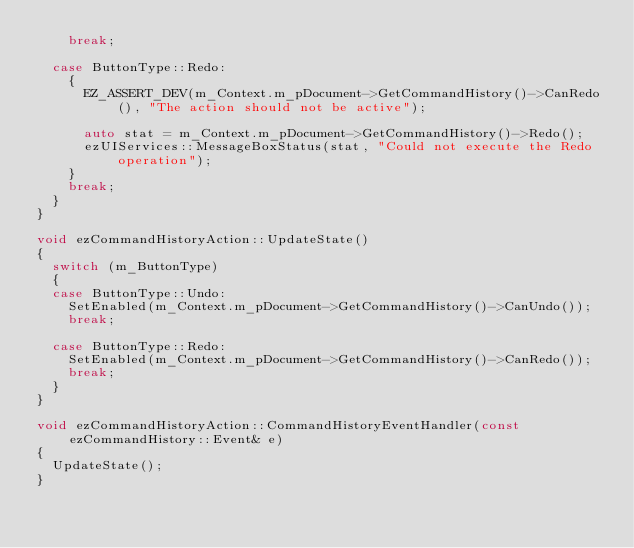Convert code to text. <code><loc_0><loc_0><loc_500><loc_500><_C++_>    break;

  case ButtonType::Redo:
    {
      EZ_ASSERT_DEV(m_Context.m_pDocument->GetCommandHistory()->CanRedo(), "The action should not be active");

      auto stat = m_Context.m_pDocument->GetCommandHistory()->Redo();
      ezUIServices::MessageBoxStatus(stat, "Could not execute the Redo operation");
    }
    break;
  }
}

void ezCommandHistoryAction::UpdateState()
{
  switch (m_ButtonType)
  {
  case ButtonType::Undo:
    SetEnabled(m_Context.m_pDocument->GetCommandHistory()->CanUndo());
    break;

  case ButtonType::Redo:
    SetEnabled(m_Context.m_pDocument->GetCommandHistory()->CanRedo());
    break;
  }
}

void ezCommandHistoryAction::CommandHistoryEventHandler(const ezCommandHistory::Event& e)
{
  UpdateState();
}</code> 